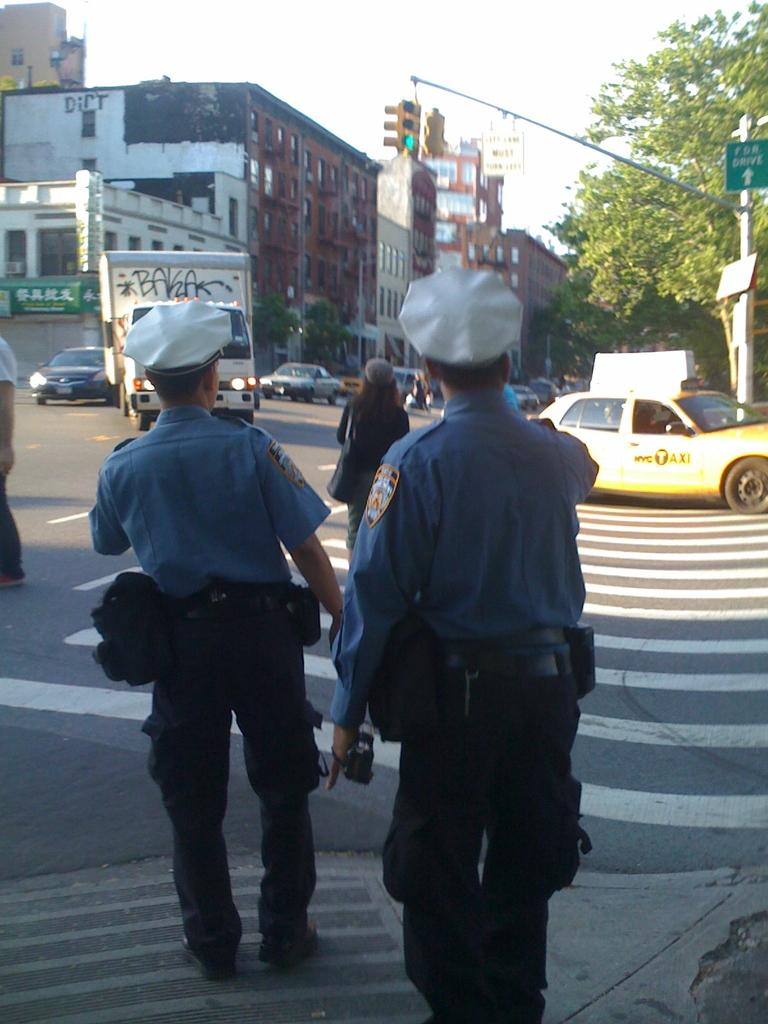What types of living organisms can be seen in the image? People can be seen in the image. What type of structures are present in the image? Buildings are present in the image. What type of vegetation is visible in the image? Trees are visible in the image. What type of transportation is present in the image? Vehicles are present in the image. What type of signage is visible in the image? Boards are visible in the image. What part of the natural environment is visible in the image? The ground and the sky are visible in the image. What type of vertical structure is present in the image? There is a pole in the image. What type of rabbit can be seen hopping on the pole in the image? There is no rabbit present in the image, and therefore no such activity can be observed. What language is being spoken by the people in the image? The image does not provide any information about the language being spoken by the people. 